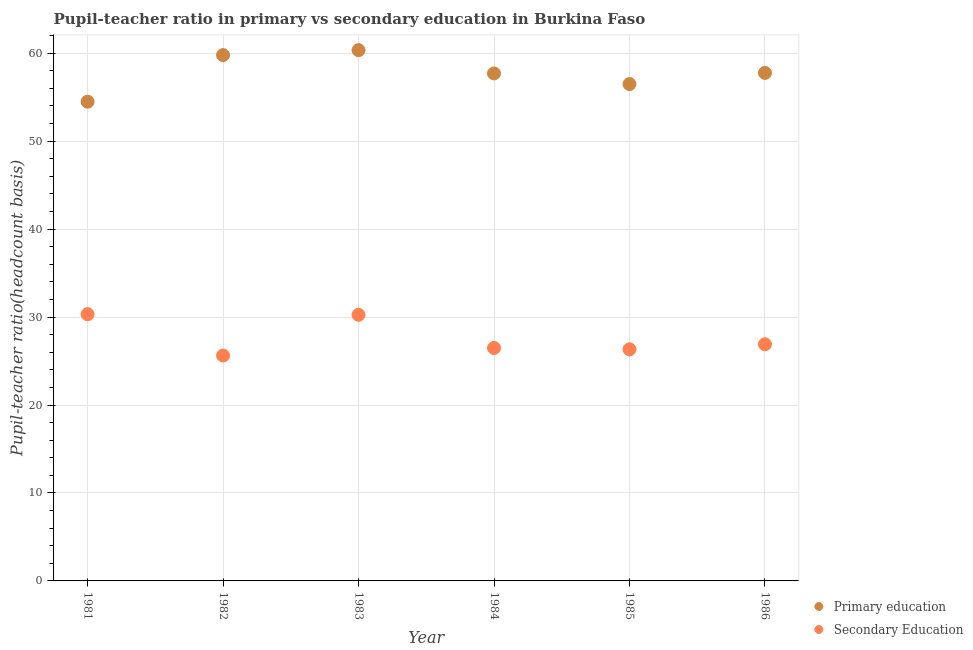What is the pupil-teacher ratio in primary education in 1985?
Make the answer very short. 56.49. Across all years, what is the maximum pupil-teacher ratio in primary education?
Provide a succinct answer. 60.35. Across all years, what is the minimum pupil-teacher ratio in primary education?
Your response must be concise. 54.49. In which year was the pupil teacher ratio on secondary education maximum?
Give a very brief answer. 1981. In which year was the pupil teacher ratio on secondary education minimum?
Give a very brief answer. 1982. What is the total pupil teacher ratio on secondary education in the graph?
Provide a short and direct response. 165.94. What is the difference between the pupil teacher ratio on secondary education in 1982 and that in 1986?
Offer a terse response. -1.28. What is the difference between the pupil teacher ratio on secondary education in 1982 and the pupil-teacher ratio in primary education in 1984?
Provide a short and direct response. -32.08. What is the average pupil-teacher ratio in primary education per year?
Provide a succinct answer. 57.76. In the year 1981, what is the difference between the pupil-teacher ratio in primary education and pupil teacher ratio on secondary education?
Offer a terse response. 24.15. What is the ratio of the pupil-teacher ratio in primary education in 1983 to that in 1985?
Ensure brevity in your answer.  1.07. Is the pupil-teacher ratio in primary education in 1982 less than that in 1984?
Your answer should be very brief. No. What is the difference between the highest and the second highest pupil teacher ratio on secondary education?
Your answer should be compact. 0.07. What is the difference between the highest and the lowest pupil-teacher ratio in primary education?
Offer a terse response. 5.86. In how many years, is the pupil teacher ratio on secondary education greater than the average pupil teacher ratio on secondary education taken over all years?
Make the answer very short. 2. Does the pupil teacher ratio on secondary education monotonically increase over the years?
Offer a terse response. No. Is the pupil teacher ratio on secondary education strictly greater than the pupil-teacher ratio in primary education over the years?
Offer a very short reply. No. How many dotlines are there?
Ensure brevity in your answer.  2. What is the difference between two consecutive major ticks on the Y-axis?
Give a very brief answer. 10. Does the graph contain any zero values?
Your answer should be very brief. No. How many legend labels are there?
Your answer should be compact. 2. How are the legend labels stacked?
Keep it short and to the point. Vertical. What is the title of the graph?
Offer a terse response. Pupil-teacher ratio in primary vs secondary education in Burkina Faso. What is the label or title of the Y-axis?
Provide a short and direct response. Pupil-teacher ratio(headcount basis). What is the Pupil-teacher ratio(headcount basis) of Primary education in 1981?
Your answer should be very brief. 54.49. What is the Pupil-teacher ratio(headcount basis) of Secondary Education in 1981?
Your response must be concise. 30.33. What is the Pupil-teacher ratio(headcount basis) in Primary education in 1982?
Your answer should be compact. 59.79. What is the Pupil-teacher ratio(headcount basis) of Secondary Education in 1982?
Your answer should be compact. 25.62. What is the Pupil-teacher ratio(headcount basis) in Primary education in 1983?
Your answer should be compact. 60.35. What is the Pupil-teacher ratio(headcount basis) of Secondary Education in 1983?
Make the answer very short. 30.26. What is the Pupil-teacher ratio(headcount basis) in Primary education in 1984?
Offer a very short reply. 57.7. What is the Pupil-teacher ratio(headcount basis) in Secondary Education in 1984?
Give a very brief answer. 26.49. What is the Pupil-teacher ratio(headcount basis) of Primary education in 1985?
Ensure brevity in your answer.  56.49. What is the Pupil-teacher ratio(headcount basis) in Secondary Education in 1985?
Provide a succinct answer. 26.33. What is the Pupil-teacher ratio(headcount basis) of Primary education in 1986?
Your answer should be very brief. 57.76. What is the Pupil-teacher ratio(headcount basis) in Secondary Education in 1986?
Your answer should be compact. 26.91. Across all years, what is the maximum Pupil-teacher ratio(headcount basis) of Primary education?
Give a very brief answer. 60.35. Across all years, what is the maximum Pupil-teacher ratio(headcount basis) in Secondary Education?
Provide a succinct answer. 30.33. Across all years, what is the minimum Pupil-teacher ratio(headcount basis) in Primary education?
Offer a terse response. 54.49. Across all years, what is the minimum Pupil-teacher ratio(headcount basis) in Secondary Education?
Give a very brief answer. 25.62. What is the total Pupil-teacher ratio(headcount basis) in Primary education in the graph?
Provide a short and direct response. 346.57. What is the total Pupil-teacher ratio(headcount basis) in Secondary Education in the graph?
Offer a terse response. 165.94. What is the difference between the Pupil-teacher ratio(headcount basis) in Primary education in 1981 and that in 1982?
Give a very brief answer. -5.3. What is the difference between the Pupil-teacher ratio(headcount basis) of Secondary Education in 1981 and that in 1982?
Provide a succinct answer. 4.71. What is the difference between the Pupil-teacher ratio(headcount basis) in Primary education in 1981 and that in 1983?
Your answer should be very brief. -5.86. What is the difference between the Pupil-teacher ratio(headcount basis) in Secondary Education in 1981 and that in 1983?
Provide a succinct answer. 0.07. What is the difference between the Pupil-teacher ratio(headcount basis) of Primary education in 1981 and that in 1984?
Provide a short and direct response. -3.22. What is the difference between the Pupil-teacher ratio(headcount basis) in Secondary Education in 1981 and that in 1984?
Give a very brief answer. 3.84. What is the difference between the Pupil-teacher ratio(headcount basis) of Primary education in 1981 and that in 1985?
Give a very brief answer. -2. What is the difference between the Pupil-teacher ratio(headcount basis) of Secondary Education in 1981 and that in 1985?
Offer a terse response. 4. What is the difference between the Pupil-teacher ratio(headcount basis) in Primary education in 1981 and that in 1986?
Ensure brevity in your answer.  -3.27. What is the difference between the Pupil-teacher ratio(headcount basis) of Secondary Education in 1981 and that in 1986?
Give a very brief answer. 3.42. What is the difference between the Pupil-teacher ratio(headcount basis) of Primary education in 1982 and that in 1983?
Provide a succinct answer. -0.56. What is the difference between the Pupil-teacher ratio(headcount basis) of Secondary Education in 1982 and that in 1983?
Offer a very short reply. -4.63. What is the difference between the Pupil-teacher ratio(headcount basis) of Primary education in 1982 and that in 1984?
Give a very brief answer. 2.09. What is the difference between the Pupil-teacher ratio(headcount basis) of Secondary Education in 1982 and that in 1984?
Your answer should be very brief. -0.86. What is the difference between the Pupil-teacher ratio(headcount basis) in Primary education in 1982 and that in 1985?
Keep it short and to the point. 3.3. What is the difference between the Pupil-teacher ratio(headcount basis) of Secondary Education in 1982 and that in 1985?
Keep it short and to the point. -0.71. What is the difference between the Pupil-teacher ratio(headcount basis) of Primary education in 1982 and that in 1986?
Provide a short and direct response. 2.03. What is the difference between the Pupil-teacher ratio(headcount basis) in Secondary Education in 1982 and that in 1986?
Provide a short and direct response. -1.28. What is the difference between the Pupil-teacher ratio(headcount basis) in Primary education in 1983 and that in 1984?
Your answer should be compact. 2.65. What is the difference between the Pupil-teacher ratio(headcount basis) of Secondary Education in 1983 and that in 1984?
Your answer should be compact. 3.77. What is the difference between the Pupil-teacher ratio(headcount basis) of Primary education in 1983 and that in 1985?
Offer a terse response. 3.86. What is the difference between the Pupil-teacher ratio(headcount basis) in Secondary Education in 1983 and that in 1985?
Offer a terse response. 3.92. What is the difference between the Pupil-teacher ratio(headcount basis) in Primary education in 1983 and that in 1986?
Make the answer very short. 2.59. What is the difference between the Pupil-teacher ratio(headcount basis) of Secondary Education in 1983 and that in 1986?
Offer a very short reply. 3.35. What is the difference between the Pupil-teacher ratio(headcount basis) in Primary education in 1984 and that in 1985?
Ensure brevity in your answer.  1.21. What is the difference between the Pupil-teacher ratio(headcount basis) in Secondary Education in 1984 and that in 1985?
Your answer should be compact. 0.16. What is the difference between the Pupil-teacher ratio(headcount basis) of Primary education in 1984 and that in 1986?
Provide a succinct answer. -0.06. What is the difference between the Pupil-teacher ratio(headcount basis) in Secondary Education in 1984 and that in 1986?
Give a very brief answer. -0.42. What is the difference between the Pupil-teacher ratio(headcount basis) in Primary education in 1985 and that in 1986?
Ensure brevity in your answer.  -1.27. What is the difference between the Pupil-teacher ratio(headcount basis) of Secondary Education in 1985 and that in 1986?
Offer a terse response. -0.58. What is the difference between the Pupil-teacher ratio(headcount basis) of Primary education in 1981 and the Pupil-teacher ratio(headcount basis) of Secondary Education in 1982?
Offer a terse response. 28.86. What is the difference between the Pupil-teacher ratio(headcount basis) of Primary education in 1981 and the Pupil-teacher ratio(headcount basis) of Secondary Education in 1983?
Keep it short and to the point. 24.23. What is the difference between the Pupil-teacher ratio(headcount basis) of Primary education in 1981 and the Pupil-teacher ratio(headcount basis) of Secondary Education in 1984?
Offer a terse response. 28. What is the difference between the Pupil-teacher ratio(headcount basis) of Primary education in 1981 and the Pupil-teacher ratio(headcount basis) of Secondary Education in 1985?
Ensure brevity in your answer.  28.15. What is the difference between the Pupil-teacher ratio(headcount basis) in Primary education in 1981 and the Pupil-teacher ratio(headcount basis) in Secondary Education in 1986?
Your answer should be very brief. 27.58. What is the difference between the Pupil-teacher ratio(headcount basis) in Primary education in 1982 and the Pupil-teacher ratio(headcount basis) in Secondary Education in 1983?
Your answer should be very brief. 29.53. What is the difference between the Pupil-teacher ratio(headcount basis) of Primary education in 1982 and the Pupil-teacher ratio(headcount basis) of Secondary Education in 1984?
Provide a short and direct response. 33.3. What is the difference between the Pupil-teacher ratio(headcount basis) of Primary education in 1982 and the Pupil-teacher ratio(headcount basis) of Secondary Education in 1985?
Your answer should be compact. 33.45. What is the difference between the Pupil-teacher ratio(headcount basis) of Primary education in 1982 and the Pupil-teacher ratio(headcount basis) of Secondary Education in 1986?
Provide a short and direct response. 32.88. What is the difference between the Pupil-teacher ratio(headcount basis) in Primary education in 1983 and the Pupil-teacher ratio(headcount basis) in Secondary Education in 1984?
Your response must be concise. 33.86. What is the difference between the Pupil-teacher ratio(headcount basis) in Primary education in 1983 and the Pupil-teacher ratio(headcount basis) in Secondary Education in 1985?
Your response must be concise. 34.02. What is the difference between the Pupil-teacher ratio(headcount basis) of Primary education in 1983 and the Pupil-teacher ratio(headcount basis) of Secondary Education in 1986?
Your answer should be compact. 33.44. What is the difference between the Pupil-teacher ratio(headcount basis) of Primary education in 1984 and the Pupil-teacher ratio(headcount basis) of Secondary Education in 1985?
Your answer should be compact. 31.37. What is the difference between the Pupil-teacher ratio(headcount basis) in Primary education in 1984 and the Pupil-teacher ratio(headcount basis) in Secondary Education in 1986?
Your answer should be compact. 30.79. What is the difference between the Pupil-teacher ratio(headcount basis) in Primary education in 1985 and the Pupil-teacher ratio(headcount basis) in Secondary Education in 1986?
Provide a short and direct response. 29.58. What is the average Pupil-teacher ratio(headcount basis) in Primary education per year?
Offer a terse response. 57.76. What is the average Pupil-teacher ratio(headcount basis) in Secondary Education per year?
Offer a very short reply. 27.66. In the year 1981, what is the difference between the Pupil-teacher ratio(headcount basis) of Primary education and Pupil-teacher ratio(headcount basis) of Secondary Education?
Your answer should be very brief. 24.15. In the year 1982, what is the difference between the Pupil-teacher ratio(headcount basis) in Primary education and Pupil-teacher ratio(headcount basis) in Secondary Education?
Keep it short and to the point. 34.16. In the year 1983, what is the difference between the Pupil-teacher ratio(headcount basis) in Primary education and Pupil-teacher ratio(headcount basis) in Secondary Education?
Your answer should be compact. 30.09. In the year 1984, what is the difference between the Pupil-teacher ratio(headcount basis) of Primary education and Pupil-teacher ratio(headcount basis) of Secondary Education?
Keep it short and to the point. 31.21. In the year 1985, what is the difference between the Pupil-teacher ratio(headcount basis) in Primary education and Pupil-teacher ratio(headcount basis) in Secondary Education?
Give a very brief answer. 30.16. In the year 1986, what is the difference between the Pupil-teacher ratio(headcount basis) of Primary education and Pupil-teacher ratio(headcount basis) of Secondary Education?
Give a very brief answer. 30.85. What is the ratio of the Pupil-teacher ratio(headcount basis) of Primary education in 1981 to that in 1982?
Provide a succinct answer. 0.91. What is the ratio of the Pupil-teacher ratio(headcount basis) in Secondary Education in 1981 to that in 1982?
Your answer should be compact. 1.18. What is the ratio of the Pupil-teacher ratio(headcount basis) of Primary education in 1981 to that in 1983?
Your response must be concise. 0.9. What is the ratio of the Pupil-teacher ratio(headcount basis) of Secondary Education in 1981 to that in 1983?
Offer a terse response. 1. What is the ratio of the Pupil-teacher ratio(headcount basis) in Primary education in 1981 to that in 1984?
Make the answer very short. 0.94. What is the ratio of the Pupil-teacher ratio(headcount basis) in Secondary Education in 1981 to that in 1984?
Ensure brevity in your answer.  1.15. What is the ratio of the Pupil-teacher ratio(headcount basis) of Primary education in 1981 to that in 1985?
Provide a succinct answer. 0.96. What is the ratio of the Pupil-teacher ratio(headcount basis) of Secondary Education in 1981 to that in 1985?
Your answer should be compact. 1.15. What is the ratio of the Pupil-teacher ratio(headcount basis) in Primary education in 1981 to that in 1986?
Your answer should be compact. 0.94. What is the ratio of the Pupil-teacher ratio(headcount basis) in Secondary Education in 1981 to that in 1986?
Offer a very short reply. 1.13. What is the ratio of the Pupil-teacher ratio(headcount basis) in Secondary Education in 1982 to that in 1983?
Provide a succinct answer. 0.85. What is the ratio of the Pupil-teacher ratio(headcount basis) in Primary education in 1982 to that in 1984?
Ensure brevity in your answer.  1.04. What is the ratio of the Pupil-teacher ratio(headcount basis) in Secondary Education in 1982 to that in 1984?
Your response must be concise. 0.97. What is the ratio of the Pupil-teacher ratio(headcount basis) of Primary education in 1982 to that in 1985?
Keep it short and to the point. 1.06. What is the ratio of the Pupil-teacher ratio(headcount basis) in Secondary Education in 1982 to that in 1985?
Provide a short and direct response. 0.97. What is the ratio of the Pupil-teacher ratio(headcount basis) in Primary education in 1982 to that in 1986?
Your answer should be very brief. 1.04. What is the ratio of the Pupil-teacher ratio(headcount basis) of Secondary Education in 1982 to that in 1986?
Provide a succinct answer. 0.95. What is the ratio of the Pupil-teacher ratio(headcount basis) in Primary education in 1983 to that in 1984?
Your answer should be very brief. 1.05. What is the ratio of the Pupil-teacher ratio(headcount basis) in Secondary Education in 1983 to that in 1984?
Keep it short and to the point. 1.14. What is the ratio of the Pupil-teacher ratio(headcount basis) in Primary education in 1983 to that in 1985?
Your answer should be very brief. 1.07. What is the ratio of the Pupil-teacher ratio(headcount basis) of Secondary Education in 1983 to that in 1985?
Make the answer very short. 1.15. What is the ratio of the Pupil-teacher ratio(headcount basis) in Primary education in 1983 to that in 1986?
Your response must be concise. 1.04. What is the ratio of the Pupil-teacher ratio(headcount basis) of Secondary Education in 1983 to that in 1986?
Provide a succinct answer. 1.12. What is the ratio of the Pupil-teacher ratio(headcount basis) of Primary education in 1984 to that in 1985?
Provide a succinct answer. 1.02. What is the ratio of the Pupil-teacher ratio(headcount basis) in Secondary Education in 1984 to that in 1985?
Offer a terse response. 1.01. What is the ratio of the Pupil-teacher ratio(headcount basis) of Secondary Education in 1984 to that in 1986?
Offer a terse response. 0.98. What is the ratio of the Pupil-teacher ratio(headcount basis) of Secondary Education in 1985 to that in 1986?
Ensure brevity in your answer.  0.98. What is the difference between the highest and the second highest Pupil-teacher ratio(headcount basis) in Primary education?
Give a very brief answer. 0.56. What is the difference between the highest and the second highest Pupil-teacher ratio(headcount basis) of Secondary Education?
Provide a succinct answer. 0.07. What is the difference between the highest and the lowest Pupil-teacher ratio(headcount basis) in Primary education?
Your answer should be very brief. 5.86. What is the difference between the highest and the lowest Pupil-teacher ratio(headcount basis) of Secondary Education?
Your answer should be very brief. 4.71. 